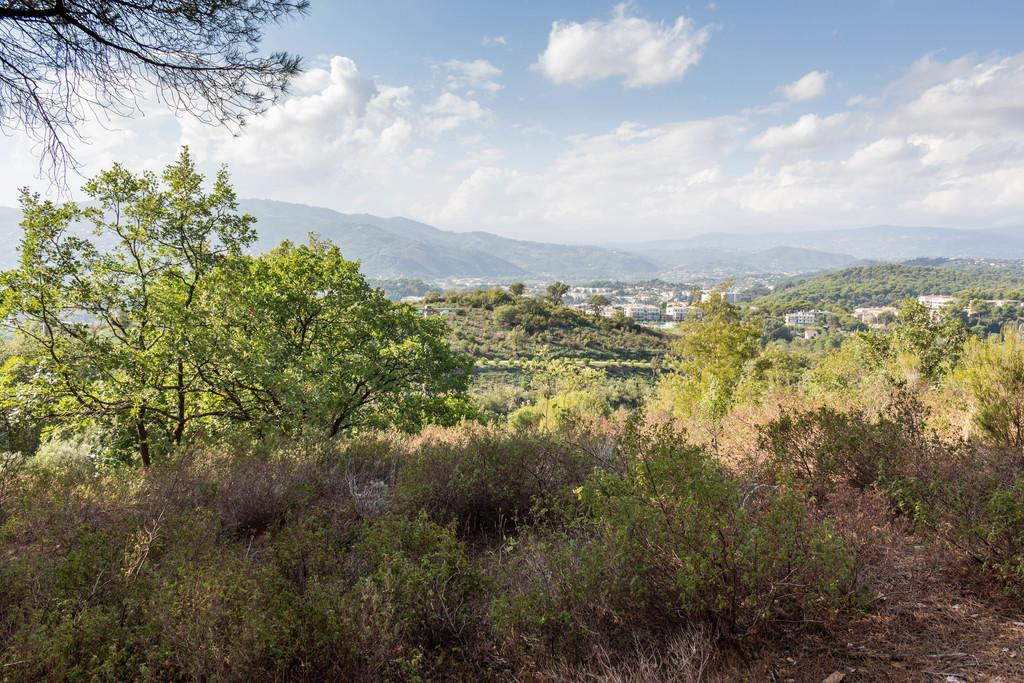What type of natural elements can be seen in the image? There are trees in the image. What type of man-made structures are present in the image? There are buildings in the image. What geographical feature is visible in the image? There is a hill in the image. How would you describe the weather in the image? The sky is cloudy in the image. What is your mom's reaction to the cloudy sky in the image? There is no reference to a mom or her reaction in the image, as the image only contains trees, buildings, a hill, and a cloudy sky. 